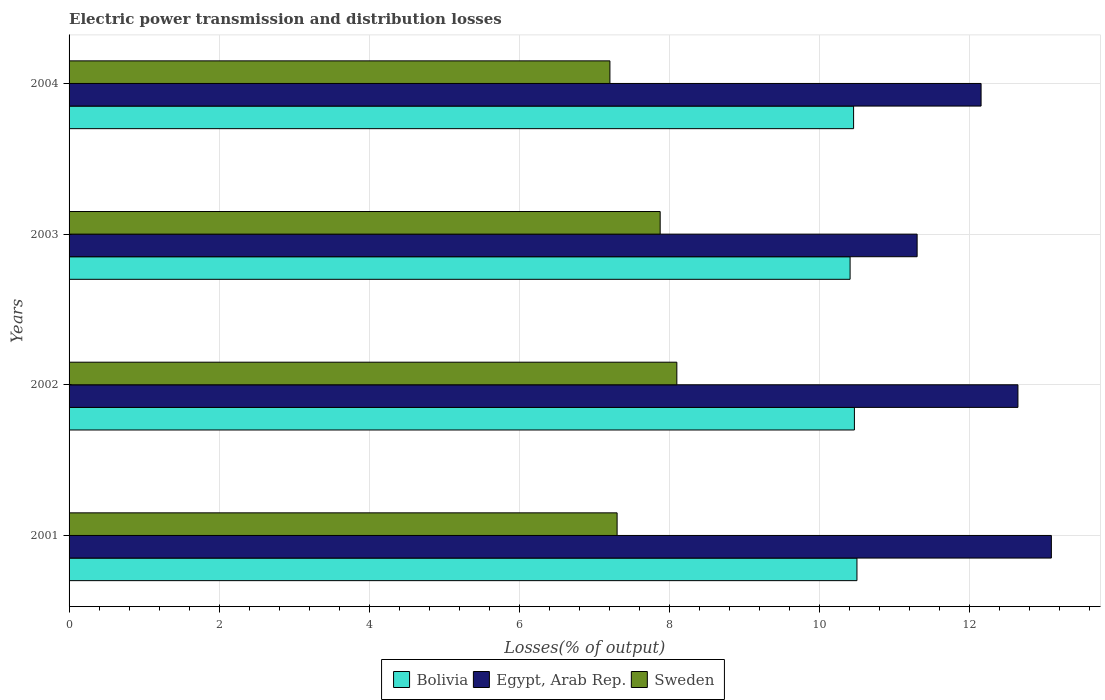Are the number of bars per tick equal to the number of legend labels?
Provide a short and direct response. Yes. Are the number of bars on each tick of the Y-axis equal?
Ensure brevity in your answer.  Yes. What is the electric power transmission and distribution losses in Sweden in 2001?
Your answer should be very brief. 7.31. Across all years, what is the maximum electric power transmission and distribution losses in Bolivia?
Your answer should be very brief. 10.5. Across all years, what is the minimum electric power transmission and distribution losses in Bolivia?
Your response must be concise. 10.41. What is the total electric power transmission and distribution losses in Bolivia in the graph?
Provide a short and direct response. 41.84. What is the difference between the electric power transmission and distribution losses in Egypt, Arab Rep. in 2003 and that in 2004?
Keep it short and to the point. -0.85. What is the difference between the electric power transmission and distribution losses in Bolivia in 2004 and the electric power transmission and distribution losses in Sweden in 2002?
Your answer should be very brief. 2.36. What is the average electric power transmission and distribution losses in Bolivia per year?
Keep it short and to the point. 10.46. In the year 2003, what is the difference between the electric power transmission and distribution losses in Sweden and electric power transmission and distribution losses in Bolivia?
Your response must be concise. -2.53. In how many years, is the electric power transmission and distribution losses in Bolivia greater than 5.2 %?
Make the answer very short. 4. What is the ratio of the electric power transmission and distribution losses in Sweden in 2003 to that in 2004?
Your answer should be very brief. 1.09. Is the electric power transmission and distribution losses in Sweden in 2002 less than that in 2004?
Offer a very short reply. No. What is the difference between the highest and the second highest electric power transmission and distribution losses in Bolivia?
Your response must be concise. 0.03. What is the difference between the highest and the lowest electric power transmission and distribution losses in Egypt, Arab Rep.?
Provide a succinct answer. 1.79. In how many years, is the electric power transmission and distribution losses in Bolivia greater than the average electric power transmission and distribution losses in Bolivia taken over all years?
Your answer should be compact. 2. Is the sum of the electric power transmission and distribution losses in Bolivia in 2001 and 2003 greater than the maximum electric power transmission and distribution losses in Egypt, Arab Rep. across all years?
Make the answer very short. Yes. What does the 3rd bar from the top in 2001 represents?
Give a very brief answer. Bolivia. What does the 2nd bar from the bottom in 2001 represents?
Keep it short and to the point. Egypt, Arab Rep. Is it the case that in every year, the sum of the electric power transmission and distribution losses in Egypt, Arab Rep. and electric power transmission and distribution losses in Sweden is greater than the electric power transmission and distribution losses in Bolivia?
Your response must be concise. Yes. How many bars are there?
Give a very brief answer. 12. Are all the bars in the graph horizontal?
Your answer should be very brief. Yes. How many years are there in the graph?
Provide a succinct answer. 4. What is the difference between two consecutive major ticks on the X-axis?
Ensure brevity in your answer.  2. Are the values on the major ticks of X-axis written in scientific E-notation?
Your answer should be compact. No. Does the graph contain any zero values?
Your response must be concise. No. Does the graph contain grids?
Give a very brief answer. Yes. How many legend labels are there?
Provide a succinct answer. 3. How are the legend labels stacked?
Ensure brevity in your answer.  Horizontal. What is the title of the graph?
Offer a very short reply. Electric power transmission and distribution losses. What is the label or title of the X-axis?
Provide a short and direct response. Losses(% of output). What is the label or title of the Y-axis?
Your response must be concise. Years. What is the Losses(% of output) of Bolivia in 2001?
Provide a short and direct response. 10.5. What is the Losses(% of output) in Egypt, Arab Rep. in 2001?
Your response must be concise. 13.09. What is the Losses(% of output) of Sweden in 2001?
Offer a very short reply. 7.31. What is the Losses(% of output) of Bolivia in 2002?
Provide a short and direct response. 10.47. What is the Losses(% of output) of Egypt, Arab Rep. in 2002?
Offer a very short reply. 12.65. What is the Losses(% of output) of Sweden in 2002?
Offer a terse response. 8.1. What is the Losses(% of output) in Bolivia in 2003?
Make the answer very short. 10.41. What is the Losses(% of output) in Egypt, Arab Rep. in 2003?
Make the answer very short. 11.3. What is the Losses(% of output) of Sweden in 2003?
Your answer should be compact. 7.88. What is the Losses(% of output) of Bolivia in 2004?
Offer a terse response. 10.46. What is the Losses(% of output) of Egypt, Arab Rep. in 2004?
Your response must be concise. 12.16. What is the Losses(% of output) of Sweden in 2004?
Keep it short and to the point. 7.21. Across all years, what is the maximum Losses(% of output) of Bolivia?
Provide a short and direct response. 10.5. Across all years, what is the maximum Losses(% of output) of Egypt, Arab Rep.?
Make the answer very short. 13.09. Across all years, what is the maximum Losses(% of output) in Sweden?
Your response must be concise. 8.1. Across all years, what is the minimum Losses(% of output) of Bolivia?
Offer a very short reply. 10.41. Across all years, what is the minimum Losses(% of output) of Egypt, Arab Rep.?
Make the answer very short. 11.3. Across all years, what is the minimum Losses(% of output) of Sweden?
Provide a short and direct response. 7.21. What is the total Losses(% of output) of Bolivia in the graph?
Your response must be concise. 41.84. What is the total Losses(% of output) of Egypt, Arab Rep. in the graph?
Offer a very short reply. 49.2. What is the total Losses(% of output) of Sweden in the graph?
Your answer should be very brief. 30.5. What is the difference between the Losses(% of output) of Bolivia in 2001 and that in 2002?
Give a very brief answer. 0.03. What is the difference between the Losses(% of output) in Egypt, Arab Rep. in 2001 and that in 2002?
Your answer should be compact. 0.45. What is the difference between the Losses(% of output) in Sweden in 2001 and that in 2002?
Give a very brief answer. -0.8. What is the difference between the Losses(% of output) of Bolivia in 2001 and that in 2003?
Your answer should be very brief. 0.09. What is the difference between the Losses(% of output) in Egypt, Arab Rep. in 2001 and that in 2003?
Ensure brevity in your answer.  1.79. What is the difference between the Losses(% of output) in Sweden in 2001 and that in 2003?
Provide a short and direct response. -0.57. What is the difference between the Losses(% of output) of Bolivia in 2001 and that in 2004?
Provide a succinct answer. 0.04. What is the difference between the Losses(% of output) in Egypt, Arab Rep. in 2001 and that in 2004?
Provide a succinct answer. 0.94. What is the difference between the Losses(% of output) in Sweden in 2001 and that in 2004?
Keep it short and to the point. 0.1. What is the difference between the Losses(% of output) of Bolivia in 2002 and that in 2003?
Ensure brevity in your answer.  0.06. What is the difference between the Losses(% of output) of Egypt, Arab Rep. in 2002 and that in 2003?
Offer a very short reply. 1.34. What is the difference between the Losses(% of output) in Sweden in 2002 and that in 2003?
Ensure brevity in your answer.  0.22. What is the difference between the Losses(% of output) of Bolivia in 2002 and that in 2004?
Your answer should be very brief. 0.01. What is the difference between the Losses(% of output) in Egypt, Arab Rep. in 2002 and that in 2004?
Offer a very short reply. 0.49. What is the difference between the Losses(% of output) of Sweden in 2002 and that in 2004?
Make the answer very short. 0.89. What is the difference between the Losses(% of output) of Bolivia in 2003 and that in 2004?
Offer a very short reply. -0.05. What is the difference between the Losses(% of output) of Egypt, Arab Rep. in 2003 and that in 2004?
Your answer should be very brief. -0.85. What is the difference between the Losses(% of output) of Sweden in 2003 and that in 2004?
Keep it short and to the point. 0.67. What is the difference between the Losses(% of output) of Bolivia in 2001 and the Losses(% of output) of Egypt, Arab Rep. in 2002?
Keep it short and to the point. -2.15. What is the difference between the Losses(% of output) in Bolivia in 2001 and the Losses(% of output) in Sweden in 2002?
Provide a succinct answer. 2.4. What is the difference between the Losses(% of output) of Egypt, Arab Rep. in 2001 and the Losses(% of output) of Sweden in 2002?
Your response must be concise. 4.99. What is the difference between the Losses(% of output) of Bolivia in 2001 and the Losses(% of output) of Egypt, Arab Rep. in 2003?
Offer a very short reply. -0.8. What is the difference between the Losses(% of output) of Bolivia in 2001 and the Losses(% of output) of Sweden in 2003?
Your response must be concise. 2.62. What is the difference between the Losses(% of output) in Egypt, Arab Rep. in 2001 and the Losses(% of output) in Sweden in 2003?
Provide a short and direct response. 5.21. What is the difference between the Losses(% of output) in Bolivia in 2001 and the Losses(% of output) in Egypt, Arab Rep. in 2004?
Give a very brief answer. -1.65. What is the difference between the Losses(% of output) of Bolivia in 2001 and the Losses(% of output) of Sweden in 2004?
Your answer should be compact. 3.29. What is the difference between the Losses(% of output) in Egypt, Arab Rep. in 2001 and the Losses(% of output) in Sweden in 2004?
Make the answer very short. 5.88. What is the difference between the Losses(% of output) of Bolivia in 2002 and the Losses(% of output) of Egypt, Arab Rep. in 2003?
Give a very brief answer. -0.84. What is the difference between the Losses(% of output) of Bolivia in 2002 and the Losses(% of output) of Sweden in 2003?
Your response must be concise. 2.59. What is the difference between the Losses(% of output) in Egypt, Arab Rep. in 2002 and the Losses(% of output) in Sweden in 2003?
Provide a short and direct response. 4.77. What is the difference between the Losses(% of output) of Bolivia in 2002 and the Losses(% of output) of Egypt, Arab Rep. in 2004?
Ensure brevity in your answer.  -1.69. What is the difference between the Losses(% of output) of Bolivia in 2002 and the Losses(% of output) of Sweden in 2004?
Provide a succinct answer. 3.26. What is the difference between the Losses(% of output) of Egypt, Arab Rep. in 2002 and the Losses(% of output) of Sweden in 2004?
Offer a terse response. 5.44. What is the difference between the Losses(% of output) of Bolivia in 2003 and the Losses(% of output) of Egypt, Arab Rep. in 2004?
Your answer should be compact. -1.75. What is the difference between the Losses(% of output) of Bolivia in 2003 and the Losses(% of output) of Sweden in 2004?
Offer a terse response. 3.2. What is the difference between the Losses(% of output) of Egypt, Arab Rep. in 2003 and the Losses(% of output) of Sweden in 2004?
Provide a succinct answer. 4.09. What is the average Losses(% of output) of Bolivia per year?
Make the answer very short. 10.46. What is the average Losses(% of output) in Egypt, Arab Rep. per year?
Provide a short and direct response. 12.3. What is the average Losses(% of output) of Sweden per year?
Make the answer very short. 7.62. In the year 2001, what is the difference between the Losses(% of output) in Bolivia and Losses(% of output) in Egypt, Arab Rep.?
Your answer should be very brief. -2.59. In the year 2001, what is the difference between the Losses(% of output) in Bolivia and Losses(% of output) in Sweden?
Your answer should be very brief. 3.2. In the year 2001, what is the difference between the Losses(% of output) of Egypt, Arab Rep. and Losses(% of output) of Sweden?
Give a very brief answer. 5.79. In the year 2002, what is the difference between the Losses(% of output) of Bolivia and Losses(% of output) of Egypt, Arab Rep.?
Your response must be concise. -2.18. In the year 2002, what is the difference between the Losses(% of output) of Bolivia and Losses(% of output) of Sweden?
Offer a very short reply. 2.37. In the year 2002, what is the difference between the Losses(% of output) in Egypt, Arab Rep. and Losses(% of output) in Sweden?
Your answer should be compact. 4.55. In the year 2003, what is the difference between the Losses(% of output) in Bolivia and Losses(% of output) in Egypt, Arab Rep.?
Offer a terse response. -0.89. In the year 2003, what is the difference between the Losses(% of output) of Bolivia and Losses(% of output) of Sweden?
Offer a terse response. 2.53. In the year 2003, what is the difference between the Losses(% of output) of Egypt, Arab Rep. and Losses(% of output) of Sweden?
Your response must be concise. 3.43. In the year 2004, what is the difference between the Losses(% of output) of Bolivia and Losses(% of output) of Egypt, Arab Rep.?
Give a very brief answer. -1.7. In the year 2004, what is the difference between the Losses(% of output) of Bolivia and Losses(% of output) of Sweden?
Your answer should be very brief. 3.25. In the year 2004, what is the difference between the Losses(% of output) of Egypt, Arab Rep. and Losses(% of output) of Sweden?
Give a very brief answer. 4.95. What is the ratio of the Losses(% of output) in Bolivia in 2001 to that in 2002?
Make the answer very short. 1. What is the ratio of the Losses(% of output) of Egypt, Arab Rep. in 2001 to that in 2002?
Give a very brief answer. 1.04. What is the ratio of the Losses(% of output) of Sweden in 2001 to that in 2002?
Your answer should be very brief. 0.9. What is the ratio of the Losses(% of output) of Bolivia in 2001 to that in 2003?
Your response must be concise. 1.01. What is the ratio of the Losses(% of output) of Egypt, Arab Rep. in 2001 to that in 2003?
Offer a terse response. 1.16. What is the ratio of the Losses(% of output) of Sweden in 2001 to that in 2003?
Offer a very short reply. 0.93. What is the ratio of the Losses(% of output) in Bolivia in 2001 to that in 2004?
Keep it short and to the point. 1. What is the ratio of the Losses(% of output) in Egypt, Arab Rep. in 2001 to that in 2004?
Give a very brief answer. 1.08. What is the ratio of the Losses(% of output) in Sweden in 2001 to that in 2004?
Keep it short and to the point. 1.01. What is the ratio of the Losses(% of output) of Egypt, Arab Rep. in 2002 to that in 2003?
Offer a very short reply. 1.12. What is the ratio of the Losses(% of output) of Sweden in 2002 to that in 2003?
Provide a short and direct response. 1.03. What is the ratio of the Losses(% of output) of Bolivia in 2002 to that in 2004?
Offer a terse response. 1. What is the ratio of the Losses(% of output) in Egypt, Arab Rep. in 2002 to that in 2004?
Keep it short and to the point. 1.04. What is the ratio of the Losses(% of output) in Sweden in 2002 to that in 2004?
Provide a short and direct response. 1.12. What is the ratio of the Losses(% of output) in Bolivia in 2003 to that in 2004?
Offer a very short reply. 1. What is the ratio of the Losses(% of output) of Egypt, Arab Rep. in 2003 to that in 2004?
Your answer should be compact. 0.93. What is the ratio of the Losses(% of output) in Sweden in 2003 to that in 2004?
Give a very brief answer. 1.09. What is the difference between the highest and the second highest Losses(% of output) of Bolivia?
Give a very brief answer. 0.03. What is the difference between the highest and the second highest Losses(% of output) of Egypt, Arab Rep.?
Offer a very short reply. 0.45. What is the difference between the highest and the second highest Losses(% of output) of Sweden?
Offer a very short reply. 0.22. What is the difference between the highest and the lowest Losses(% of output) of Bolivia?
Provide a short and direct response. 0.09. What is the difference between the highest and the lowest Losses(% of output) in Egypt, Arab Rep.?
Ensure brevity in your answer.  1.79. What is the difference between the highest and the lowest Losses(% of output) in Sweden?
Provide a succinct answer. 0.89. 